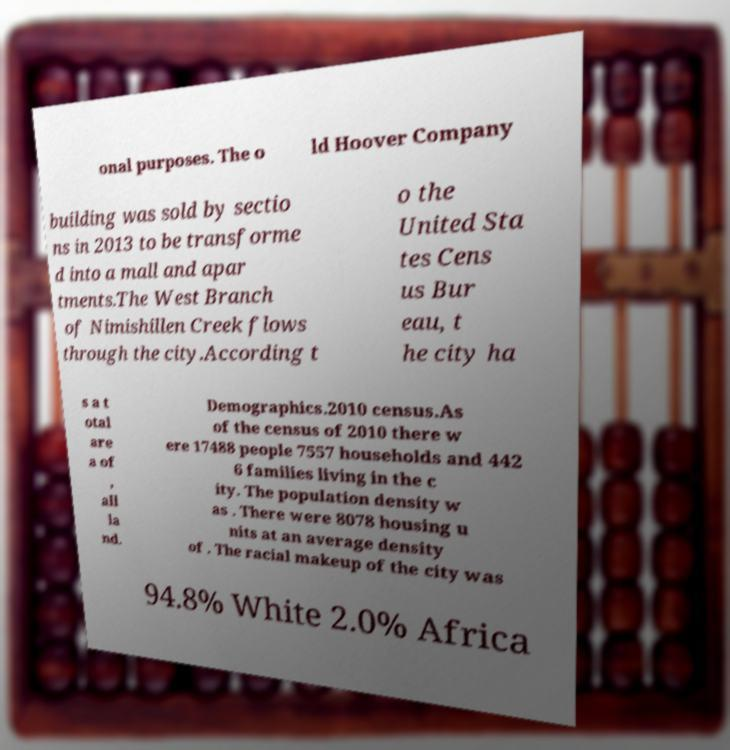I need the written content from this picture converted into text. Can you do that? onal purposes. The o ld Hoover Company building was sold by sectio ns in 2013 to be transforme d into a mall and apar tments.The West Branch of Nimishillen Creek flows through the city.According t o the United Sta tes Cens us Bur eau, t he city ha s a t otal are a of , all la nd. Demographics.2010 census.As of the census of 2010 there w ere 17488 people 7557 households and 442 6 families living in the c ity. The population density w as . There were 8078 housing u nits at an average density of . The racial makeup of the city was 94.8% White 2.0% Africa 